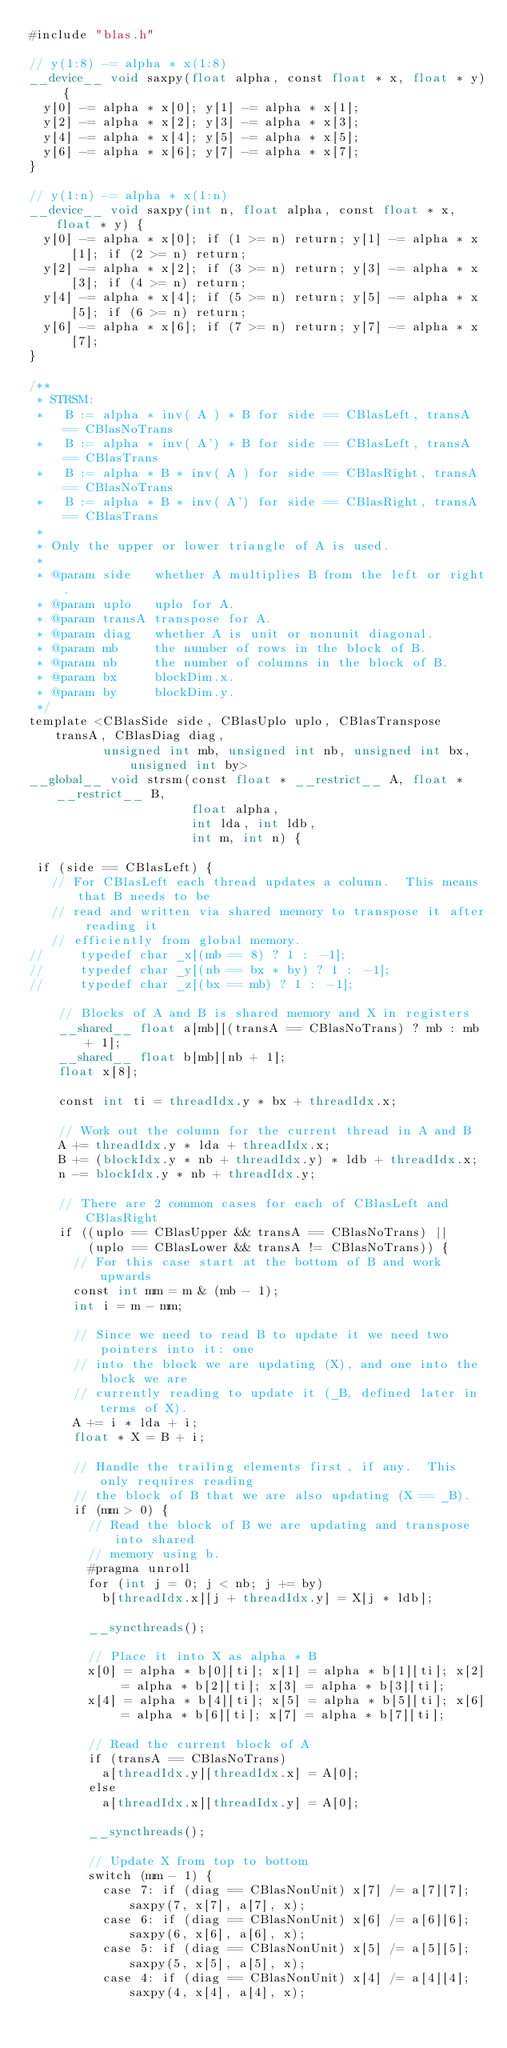<code> <loc_0><loc_0><loc_500><loc_500><_Cuda_>#include "blas.h"

// y(1:8) -= alpha * x(1:8)
__device__ void saxpy(float alpha, const float * x, float * y) {
  y[0] -= alpha * x[0]; y[1] -= alpha * x[1];
  y[2] -= alpha * x[2]; y[3] -= alpha * x[3];
  y[4] -= alpha * x[4]; y[5] -= alpha * x[5];
  y[6] -= alpha * x[6]; y[7] -= alpha * x[7];
}

// y(1:n) -= alpha * x(1:n)
__device__ void saxpy(int n, float alpha, const float * x, float * y) {
  y[0] -= alpha * x[0]; if (1 >= n) return; y[1] -= alpha * x[1]; if (2 >= n) return;
  y[2] -= alpha * x[2]; if (3 >= n) return; y[3] -= alpha * x[3]; if (4 >= n) return;
  y[4] -= alpha * x[4]; if (5 >= n) return; y[5] -= alpha * x[5]; if (6 >= n) return;
  y[6] -= alpha * x[6]; if (7 >= n) return; y[7] -= alpha * x[7];
}

/**
 * STRSM:
 *   B := alpha * inv( A ) * B for side == CBlasLeft, transA == CBlasNoTrans
 *   B := alpha * inv( A') * B for side == CBlasLeft, transA == CBlasTrans
 *   B := alpha * B * inv( A ) for side == CBlasRight, transA == CBlasNoTrans
 *   B := alpha * B * inv( A') for side == CBlasRight, transA == CBlasTrans
 *
 * Only the upper or lower triangle of A is used.
 *
 * @param side   whether A multiplies B from the left or right.
 * @param uplo   uplo for A.
 * @param transA transpose for A.
 * @param diag   whether A is unit or nonunit diagonal.
 * @param mb     the number of rows in the block of B.
 * @param nb     the number of columns in the block of B.
 * @param bx     blockDim.x.
 * @param by     blockDim.y.
 */
template <CBlasSide side, CBlasUplo uplo, CBlasTranspose transA, CBlasDiag diag,
          unsigned int mb, unsigned int nb, unsigned int bx, unsigned int by>
__global__ void strsm(const float * __restrict__ A, float * __restrict__ B,
                      float alpha,
                      int lda, int ldb,
                      int m, int n) {

 if (side == CBlasLeft) {
   // For CBlasLeft each thread updates a column.  This means that B needs to be
   // read and written via shared memory to transpose it after reading it
   // efficiently from global memory.
//     typedef char _x[(mb == 8) ? 1 : -1];
//     typedef char _y[(nb == bx * by) ? 1 : -1];
//     typedef char _z[(bx == mb) ? 1 : -1];

    // Blocks of A and B is shared memory and X in registers
    __shared__ float a[mb][(transA == CBlasNoTrans) ? mb : mb + 1];
    __shared__ float b[mb][nb + 1];
    float x[8];

    const int ti = threadIdx.y * bx + threadIdx.x;

    // Work out the column for the current thread in A and B
    A += threadIdx.y * lda + threadIdx.x;
    B += (blockIdx.y * nb + threadIdx.y) * ldb + threadIdx.x;
    n -= blockIdx.y * nb + threadIdx.y;

    // There are 2 common cases for each of CBlasLeft and CBlasRight
    if ((uplo == CBlasUpper && transA == CBlasNoTrans) ||
        (uplo == CBlasLower && transA != CBlasNoTrans)) {
      // For this case start at the bottom of B and work upwards
      const int mm = m & (mb - 1);
      int i = m - mm;

      // Since we need to read B to update it we need two pointers into it: one
      // into the block we are updating (X), and one into the block we are
      // currently reading to update it (_B, defined later in terms of X).
      A += i * lda + i;
      float * X = B + i;

      // Handle the trailing elements first, if any.  This only requires reading
      // the block of B that we are also updating (X == _B).
      if (mm > 0) {
        // Read the block of B we are updating and transpose into shared
        // memory using b.
        #pragma unroll
        for (int j = 0; j < nb; j += by)
          b[threadIdx.x][j + threadIdx.y] = X[j * ldb];

        __syncthreads();

        // Place it into X as alpha * B
        x[0] = alpha * b[0][ti]; x[1] = alpha * b[1][ti]; x[2] = alpha * b[2][ti]; x[3] = alpha * b[3][ti];
        x[4] = alpha * b[4][ti]; x[5] = alpha * b[5][ti]; x[6] = alpha * b[6][ti]; x[7] = alpha * b[7][ti];

        // Read the current block of A
        if (transA == CBlasNoTrans)
          a[threadIdx.y][threadIdx.x] = A[0];
        else
          a[threadIdx.x][threadIdx.y] = A[0];

        __syncthreads();

        // Update X from top to bottom
        switch (mm - 1) {
          case 7: if (diag == CBlasNonUnit) x[7] /= a[7][7]; saxpy(7, x[7], a[7], x);
          case 6: if (diag == CBlasNonUnit) x[6] /= a[6][6]; saxpy(6, x[6], a[6], x);
          case 5: if (diag == CBlasNonUnit) x[5] /= a[5][5]; saxpy(5, x[5], a[5], x);
          case 4: if (diag == CBlasNonUnit) x[4] /= a[4][4]; saxpy(4, x[4], a[4], x);</code> 